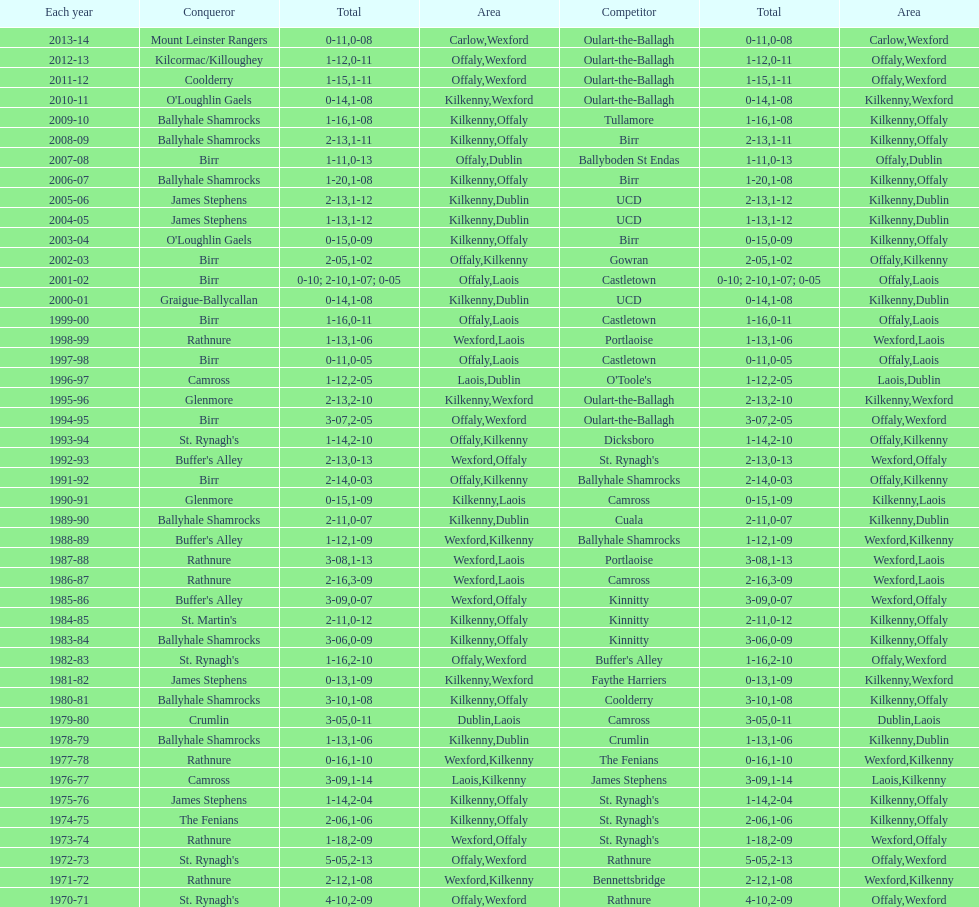Which winner is next to mount leinster rangers? Kilcormac/Killoughey. 